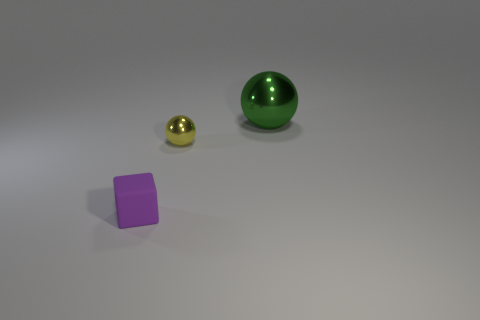Add 3 small shiny balls. How many objects exist? 6 Subtract all cubes. How many objects are left? 2 Add 3 tiny yellow shiny balls. How many tiny yellow shiny balls are left? 4 Add 1 tiny purple matte objects. How many tiny purple matte objects exist? 2 Subtract 0 cyan balls. How many objects are left? 3 Subtract all tiny objects. Subtract all big gray cylinders. How many objects are left? 1 